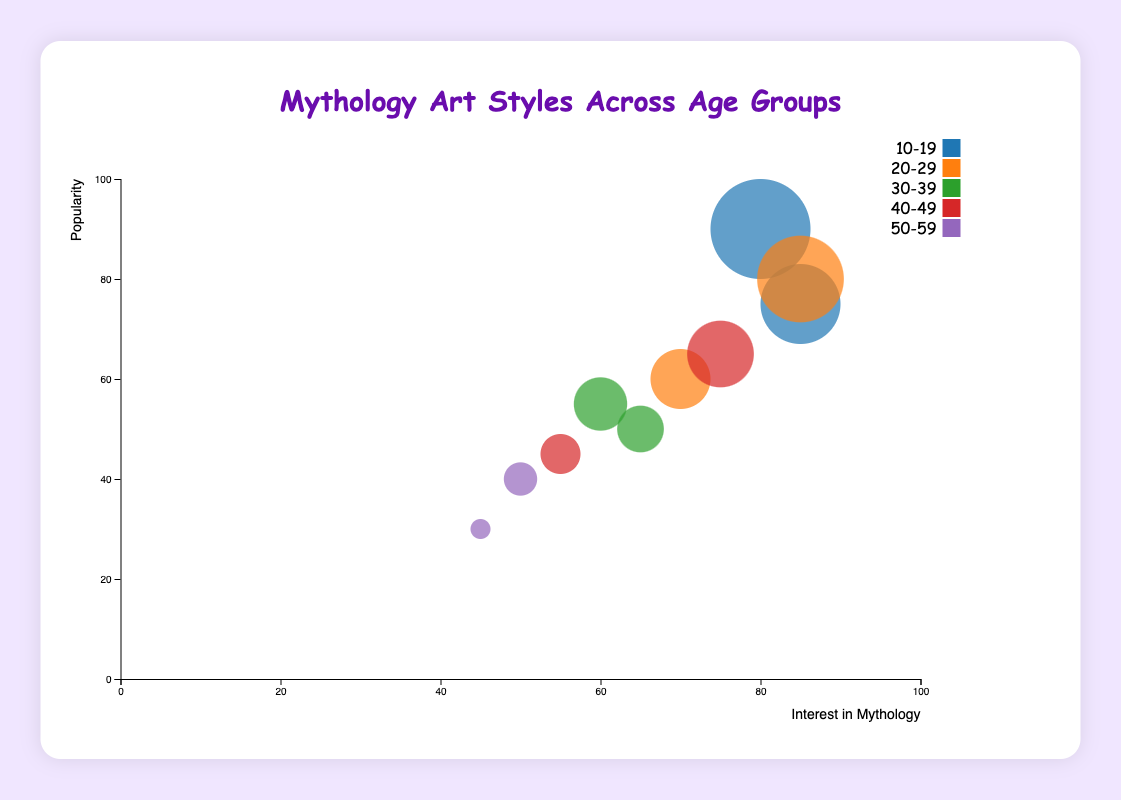What's the title of the chart? The title is displayed prominently at the top of the chart in a large, colored font.
Answer: Mythology Art Styles Across Age Groups What does the x-axis represent? The x-axis usually has a label at the bottom or side; in this case, it clearly states "Interest in Mythology".
Answer: Interest in Mythology Which age group prefers anime the most? Each bubble represents a combination of age groups and art styles. The largest bubble for "Anime" corresponds to the "10-19" age group.
Answer: 10-19 Which art style has the least overall popularity? By observing the bubble sizes, the smallest bubble corresponds to "Cubism" which has the lowest popularity value.
Answer: Cubism Which age group shows the highest interest in mythology? The x-axis represents interest in mythology. Looking at the farthest right bubbles, the "10-19" and "20-29" age groups both have a value of 85.
Answer: 10-19 and 20-29 What colors are used for different age groups? The legend in the chart lists the colors associated with each age group.
Answer: 10-19 (blue), 20-29 (orange), 30-39 (green), 40-49 (red), 50-59 (purple) What is the average popularity for the "30-39" age group? The "30-39" age group has two data points: one for "Abstract" (50) and another for "Classical" (55). The average can be calculated as (50 + 55) / 2.
Answer: 52.5 What art style is most preferred by the "40-49" age group? The largest bubble in the "40-49" category would indicate the most preferred art style, which is "Surrealism" with the larger bubble.
Answer: Surrealism Which age group shows the least interest in mythology? The smallest value on the x-axis is for the "50-59" group with "Cubism" showing an interest of 45.
Answer: 50-59 How does the popularity of "Fantasy" for the "20-29" age group compare to the "Surrealism" for the "40-49" age group? By comparing the bubble sizes and the y-axis values, "Fantasy" (80) has greater popularity compared to "Surrealism" (65) for these age groups.
Answer: Fantasy is more popular 